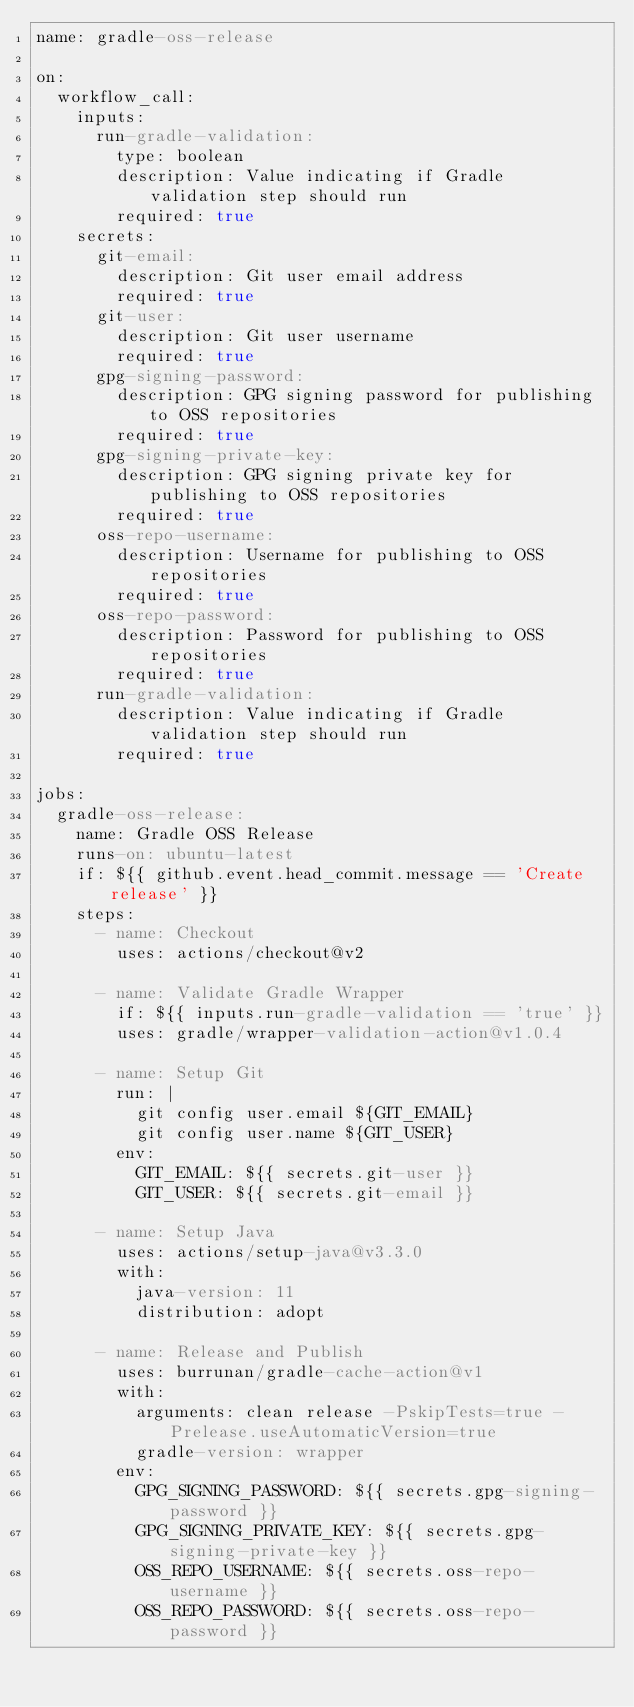Convert code to text. <code><loc_0><loc_0><loc_500><loc_500><_YAML_>name: gradle-oss-release

on:
  workflow_call:
    inputs:
      run-gradle-validation:
        type: boolean
        description: Value indicating if Gradle validation step should run
        required: true
    secrets:
      git-email:
        description: Git user email address
        required: true
      git-user:
        description: Git user username
        required: true
      gpg-signing-password:
        description: GPG signing password for publishing to OSS repositories
        required: true
      gpg-signing-private-key:
        description: GPG signing private key for publishing to OSS repositories
        required: true
      oss-repo-username:
        description: Username for publishing to OSS repositories
        required: true
      oss-repo-password:
        description: Password for publishing to OSS repositories
        required: true
      run-gradle-validation:
        description: Value indicating if Gradle validation step should run
        required: true

jobs:
  gradle-oss-release:
    name: Gradle OSS Release
    runs-on: ubuntu-latest
    if: ${{ github.event.head_commit.message == 'Create release' }}
    steps:
      - name: Checkout
        uses: actions/checkout@v2

      - name: Validate Gradle Wrapper
        if: ${{ inputs.run-gradle-validation == 'true' }}
        uses: gradle/wrapper-validation-action@v1.0.4

      - name: Setup Git
        run: |
          git config user.email ${GIT_EMAIL}
          git config user.name ${GIT_USER}
        env:
          GIT_EMAIL: ${{ secrets.git-user }}
          GIT_USER: ${{ secrets.git-email }}

      - name: Setup Java
        uses: actions/setup-java@v3.3.0
        with:
          java-version: 11
          distribution: adopt

      - name: Release and Publish
        uses: burrunan/gradle-cache-action@v1
        with:
          arguments: clean release -PskipTests=true -Prelease.useAutomaticVersion=true
          gradle-version: wrapper
        env:
          GPG_SIGNING_PASSWORD: ${{ secrets.gpg-signing-password }}
          GPG_SIGNING_PRIVATE_KEY: ${{ secrets.gpg-signing-private-key }}
          OSS_REPO_USERNAME: ${{ secrets.oss-repo-username }}
          OSS_REPO_PASSWORD: ${{ secrets.oss-repo-password }}
</code> 